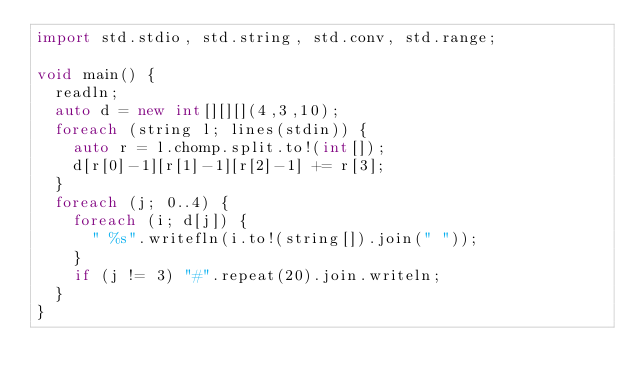Convert code to text. <code><loc_0><loc_0><loc_500><loc_500><_D_>import std.stdio, std.string, std.conv, std.range;

void main() {
	readln;
	auto d = new int[][][](4,3,10);
	foreach (string l; lines(stdin)) {
		auto r = l.chomp.split.to!(int[]);
		d[r[0]-1][r[1]-1][r[2]-1] += r[3];
	}
	foreach (j; 0..4) {
		foreach (i; d[j]) {
			" %s".writefln(i.to!(string[]).join(" "));
		}
		if (j != 3) "#".repeat(20).join.writeln;
	}
}</code> 